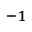<formula> <loc_0><loc_0><loc_500><loc_500>^ { - 1 }</formula> 